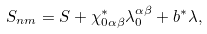Convert formula to latex. <formula><loc_0><loc_0><loc_500><loc_500>S _ { n m } = S + \chi _ { 0 \alpha \beta } ^ { * } \lambda _ { 0 } ^ { \alpha \beta } + b ^ { * } \lambda ,</formula> 